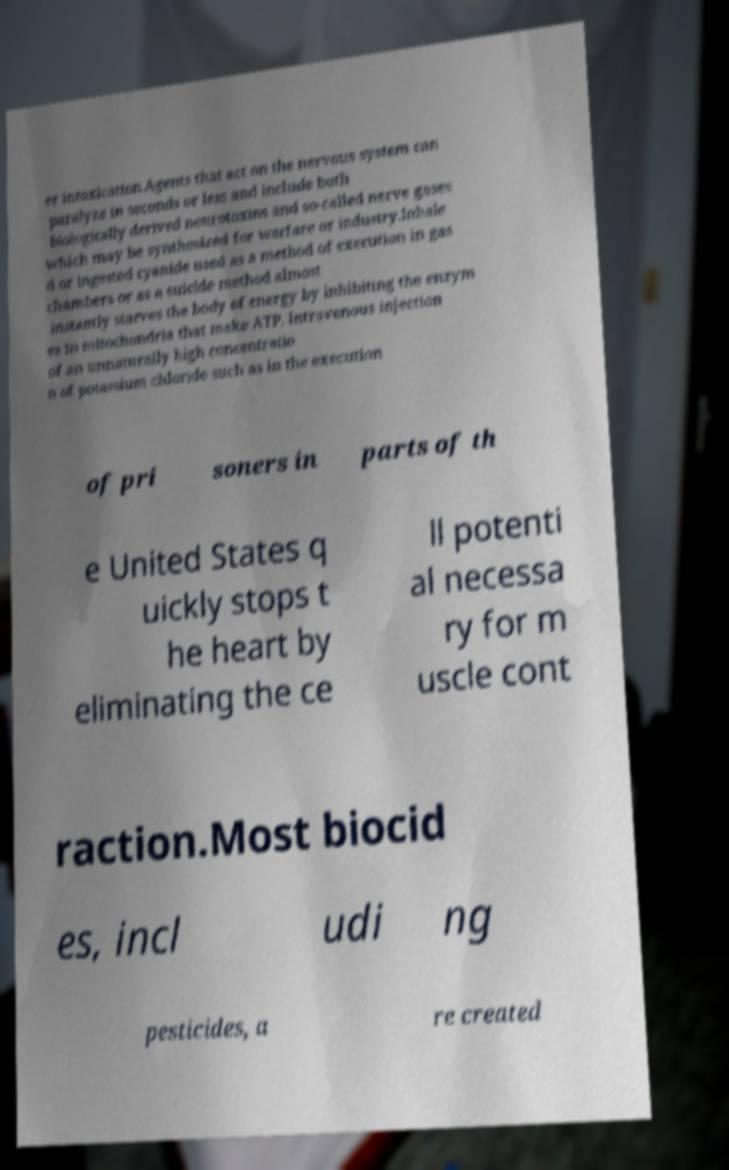Could you extract and type out the text from this image? er intoxication.Agents that act on the nervous system can paralyze in seconds or less and include both biologically derived neurotoxins and so-called nerve gases which may be synthesized for warfare or industry.Inhale d or ingested cyanide used as a method of execution in gas chambers or as a suicide method almost instantly starves the body of energy by inhibiting the enzym es in mitochondria that make ATP. Intravenous injection of an unnaturally high concentratio n of potassium chloride such as in the execution of pri soners in parts of th e United States q uickly stops t he heart by eliminating the ce ll potenti al necessa ry for m uscle cont raction.Most biocid es, incl udi ng pesticides, a re created 